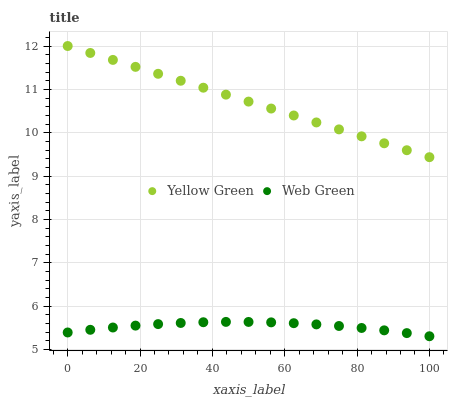Does Web Green have the minimum area under the curve?
Answer yes or no. Yes. Does Yellow Green have the maximum area under the curve?
Answer yes or no. Yes. Does Web Green have the maximum area under the curve?
Answer yes or no. No. Is Yellow Green the smoothest?
Answer yes or no. Yes. Is Web Green the roughest?
Answer yes or no. Yes. Is Web Green the smoothest?
Answer yes or no. No. Does Web Green have the lowest value?
Answer yes or no. Yes. Does Yellow Green have the highest value?
Answer yes or no. Yes. Does Web Green have the highest value?
Answer yes or no. No. Is Web Green less than Yellow Green?
Answer yes or no. Yes. Is Yellow Green greater than Web Green?
Answer yes or no. Yes. Does Web Green intersect Yellow Green?
Answer yes or no. No. 